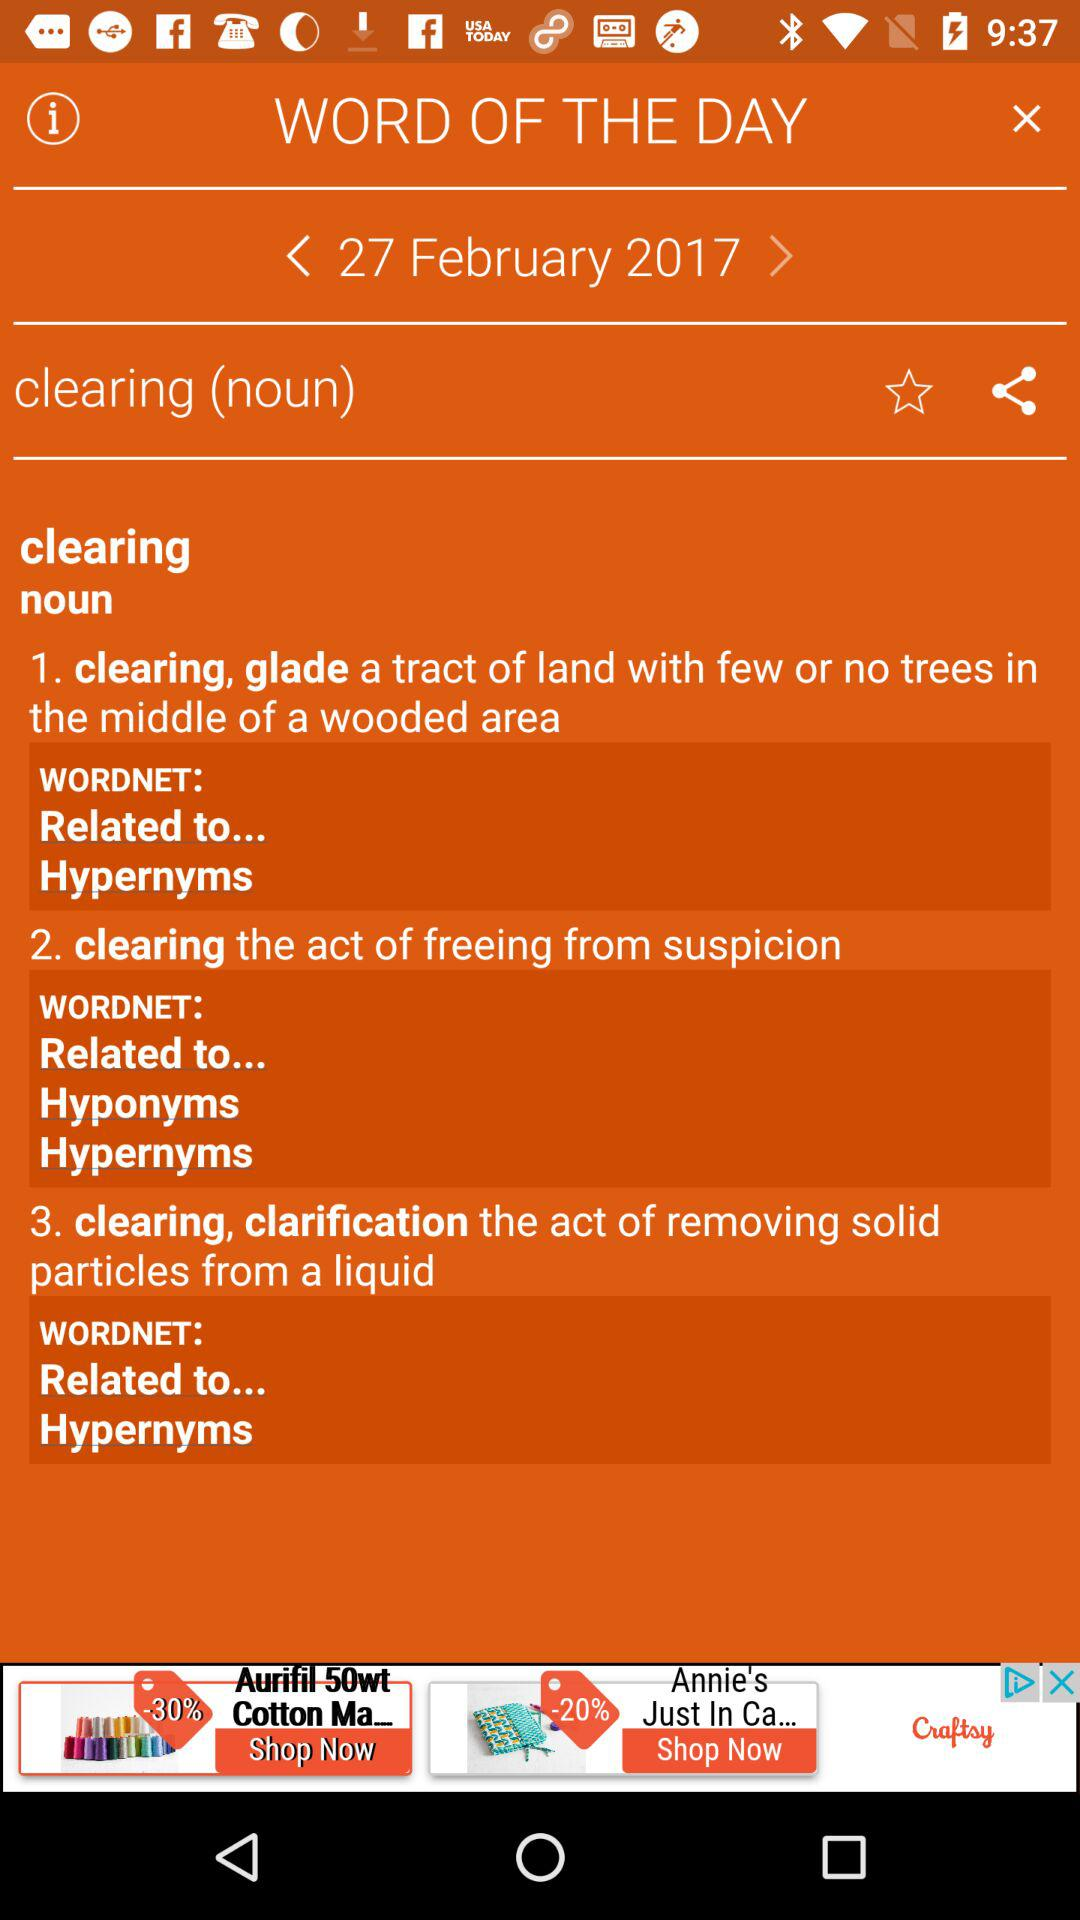What date is mentioned? The mentioned date is February 27, 2017. 